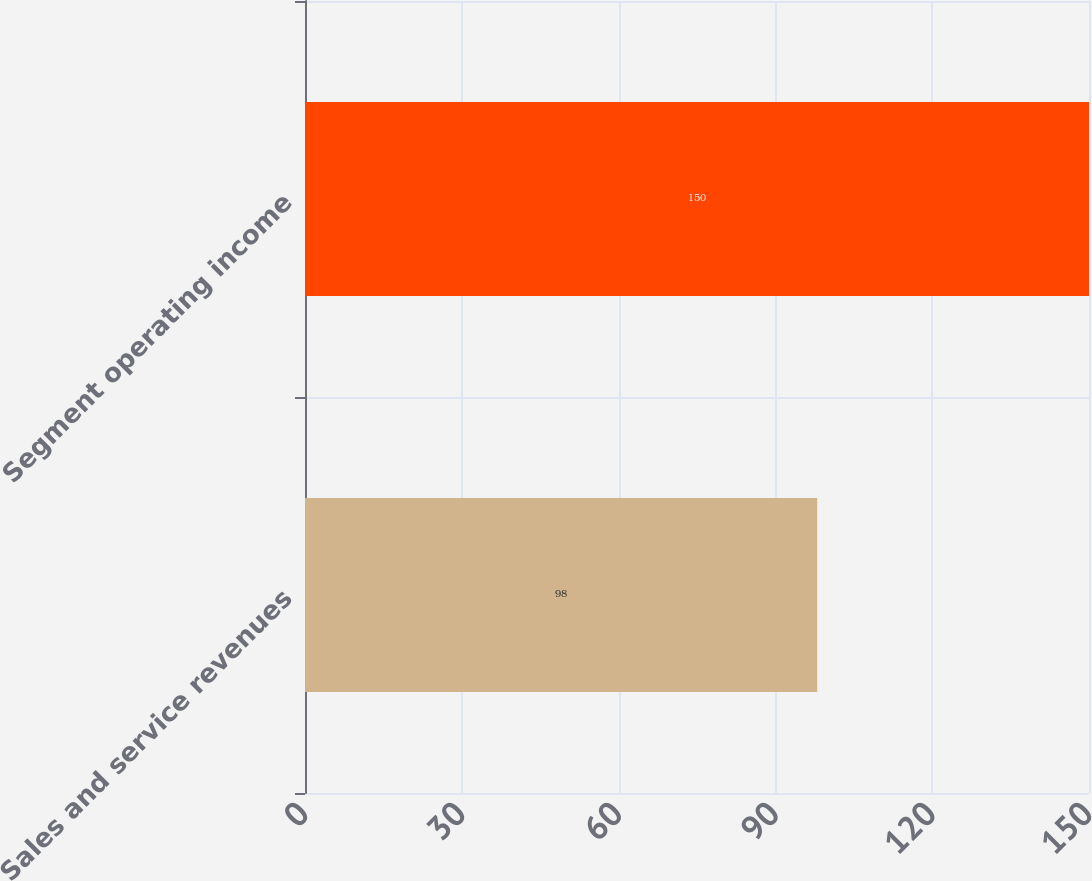Convert chart to OTSL. <chart><loc_0><loc_0><loc_500><loc_500><bar_chart><fcel>Sales and service revenues<fcel>Segment operating income<nl><fcel>98<fcel>150<nl></chart> 